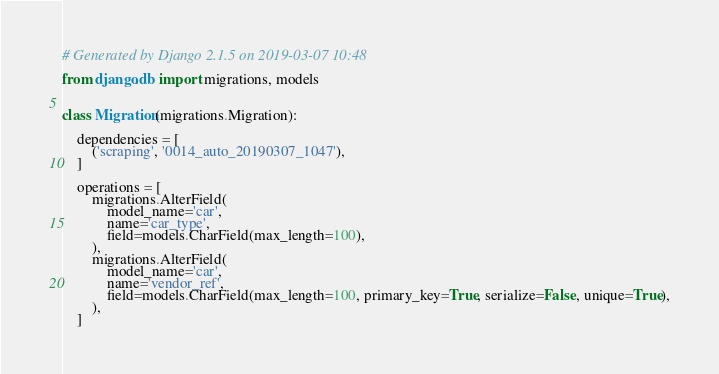Convert code to text. <code><loc_0><loc_0><loc_500><loc_500><_Python_># Generated by Django 2.1.5 on 2019-03-07 10:48

from django.db import migrations, models


class Migration(migrations.Migration):

    dependencies = [
        ('scraping', '0014_auto_20190307_1047'),
    ]

    operations = [
        migrations.AlterField(
            model_name='car',
            name='car_type',
            field=models.CharField(max_length=100),
        ),
        migrations.AlterField(
            model_name='car',
            name='vendor_ref',
            field=models.CharField(max_length=100, primary_key=True, serialize=False, unique=True),
        ),
    ]
</code> 